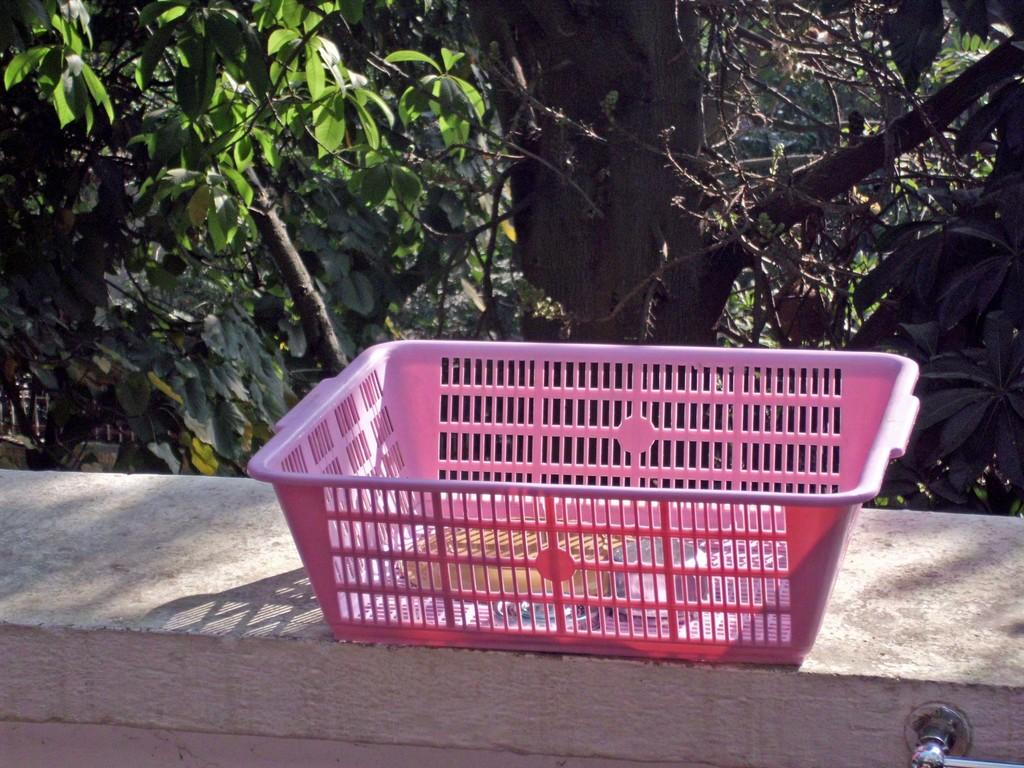What is the color of the basket in the image? The basket in the image is pink. Where is the basket located in the image? The basket is on a platform. What can be seen in the background of the image? There are trees in the background of the image. How many sticks are used in the process depicted in the image? There are no sticks or any process depicted in the image; it features a pink basket on a platform with trees in the background. 